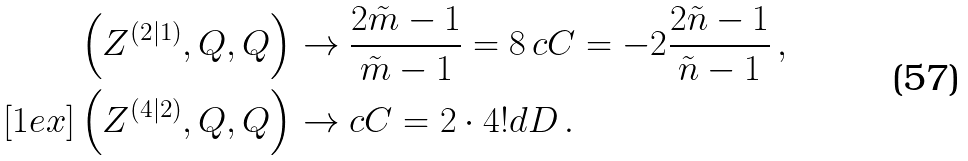<formula> <loc_0><loc_0><loc_500><loc_500>\left ( Z ^ { ( 2 | 1 ) } , Q , Q \right ) & \rightarrow \frac { 2 \tilde { m } - 1 } { \tilde { m } - 1 } = 8 \, c C = - 2 \frac { 2 \tilde { n } - 1 } { \tilde { n } - 1 } \, , \\ [ 1 e x ] \left ( Z ^ { ( 4 | 2 ) } , Q , Q \right ) & \rightarrow c C = 2 \cdot 4 ! d D \, .</formula> 